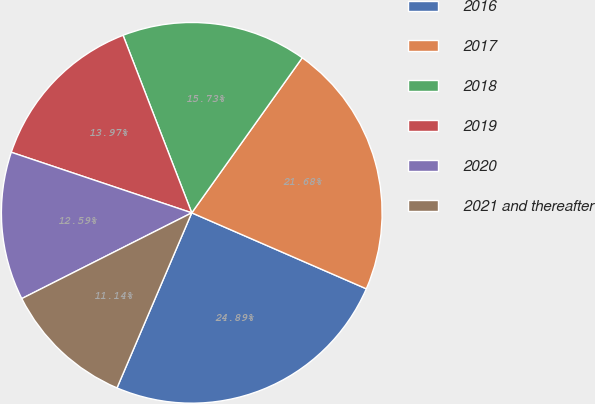Convert chart to OTSL. <chart><loc_0><loc_0><loc_500><loc_500><pie_chart><fcel>2016<fcel>2017<fcel>2018<fcel>2019<fcel>2020<fcel>2021 and thereafter<nl><fcel>24.89%<fcel>21.68%<fcel>15.73%<fcel>13.97%<fcel>12.59%<fcel>11.14%<nl></chart> 